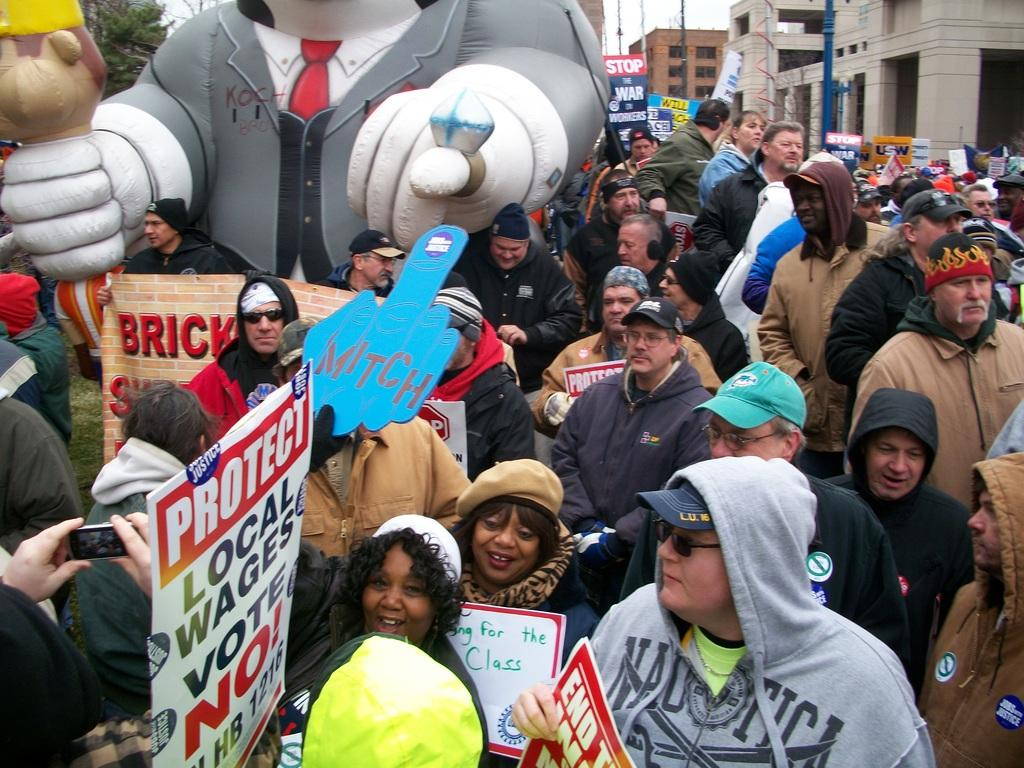How many people are in the image? There is a group of people in the image. What can be seen on the walls or surfaces in the image? There are posters in the image. What are the tall, vertical structures in the image? There are poles in the image. What is used to capture the image? There is a camera in the image. What type of ground surface is visible in the image? There is grass in the image. What type of vegetation is visible in the image? There are trees in the image. What other objects can be seen in the image? There are some objects in the image. What can be seen in the distance in the image? There are buildings in the background of the image, and the sky is visible in the background of the image. What type of canvas is being used by the tramp in the image? There is no tramp or canvas present in the image. What can be heard from the people in the image? The text does not mention any sounds or conversations, so it cannot be determined what can be heard from the people in the image. 